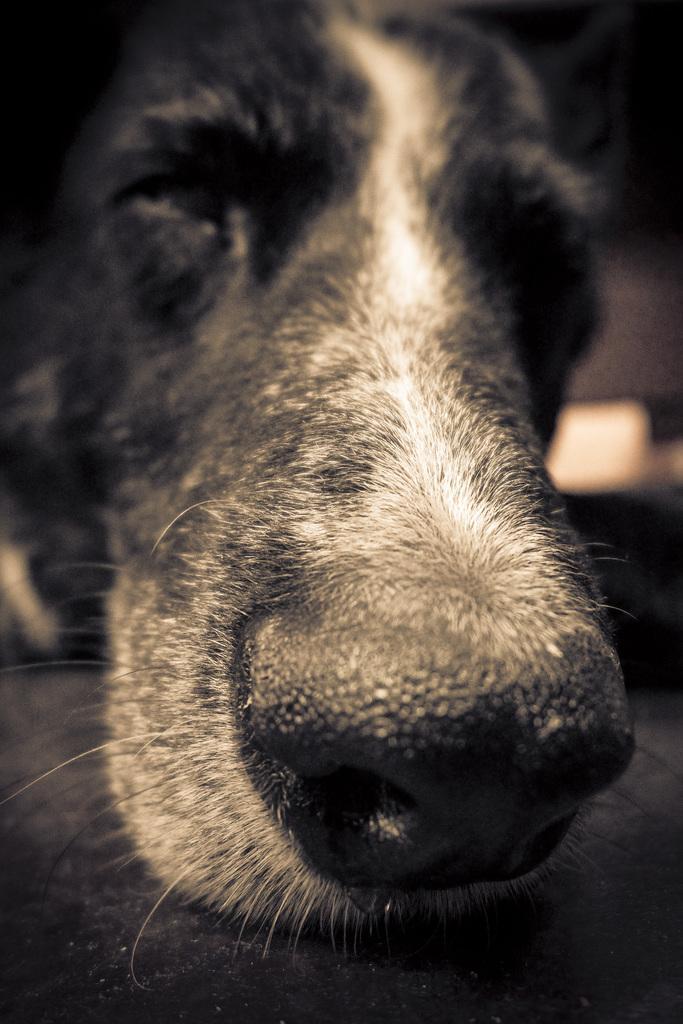Can you describe this image briefly? In this image we can see the face of the dog. 